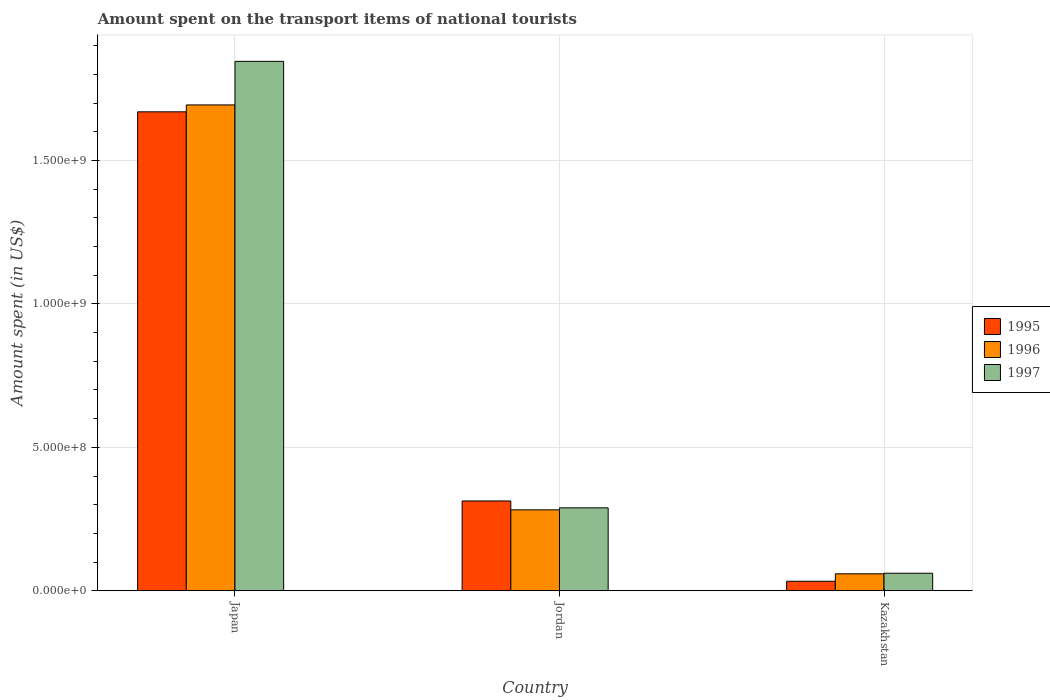How many different coloured bars are there?
Keep it short and to the point. 3. Are the number of bars per tick equal to the number of legend labels?
Provide a short and direct response. Yes. How many bars are there on the 2nd tick from the left?
Provide a succinct answer. 3. What is the label of the 1st group of bars from the left?
Your response must be concise. Japan. In how many cases, is the number of bars for a given country not equal to the number of legend labels?
Ensure brevity in your answer.  0. What is the amount spent on the transport items of national tourists in 1996 in Kazakhstan?
Ensure brevity in your answer.  5.90e+07. Across all countries, what is the maximum amount spent on the transport items of national tourists in 1995?
Ensure brevity in your answer.  1.67e+09. Across all countries, what is the minimum amount spent on the transport items of national tourists in 1995?
Keep it short and to the point. 3.30e+07. In which country was the amount spent on the transport items of national tourists in 1995 maximum?
Make the answer very short. Japan. In which country was the amount spent on the transport items of national tourists in 1997 minimum?
Give a very brief answer. Kazakhstan. What is the total amount spent on the transport items of national tourists in 1995 in the graph?
Your answer should be very brief. 2.02e+09. What is the difference between the amount spent on the transport items of national tourists in 1996 in Japan and that in Jordan?
Keep it short and to the point. 1.41e+09. What is the difference between the amount spent on the transport items of national tourists in 1997 in Jordan and the amount spent on the transport items of national tourists in 1995 in Japan?
Give a very brief answer. -1.38e+09. What is the average amount spent on the transport items of national tourists in 1997 per country?
Make the answer very short. 7.32e+08. What is the difference between the amount spent on the transport items of national tourists of/in 1997 and amount spent on the transport items of national tourists of/in 1995 in Jordan?
Provide a short and direct response. -2.40e+07. What is the ratio of the amount spent on the transport items of national tourists in 1995 in Japan to that in Jordan?
Your response must be concise. 5.34. Is the amount spent on the transport items of national tourists in 1997 in Jordan less than that in Kazakhstan?
Provide a succinct answer. No. Is the difference between the amount spent on the transport items of national tourists in 1997 in Japan and Kazakhstan greater than the difference between the amount spent on the transport items of national tourists in 1995 in Japan and Kazakhstan?
Your response must be concise. Yes. What is the difference between the highest and the second highest amount spent on the transport items of national tourists in 1996?
Offer a very short reply. 1.41e+09. What is the difference between the highest and the lowest amount spent on the transport items of national tourists in 1997?
Keep it short and to the point. 1.78e+09. Is the sum of the amount spent on the transport items of national tourists in 1995 in Japan and Kazakhstan greater than the maximum amount spent on the transport items of national tourists in 1996 across all countries?
Your response must be concise. Yes. What does the 2nd bar from the right in Kazakhstan represents?
Give a very brief answer. 1996. Is it the case that in every country, the sum of the amount spent on the transport items of national tourists in 1997 and amount spent on the transport items of national tourists in 1996 is greater than the amount spent on the transport items of national tourists in 1995?
Provide a succinct answer. Yes. How many bars are there?
Give a very brief answer. 9. Are all the bars in the graph horizontal?
Offer a very short reply. No. How many countries are there in the graph?
Make the answer very short. 3. Are the values on the major ticks of Y-axis written in scientific E-notation?
Ensure brevity in your answer.  Yes. Does the graph contain any zero values?
Offer a terse response. No. Does the graph contain grids?
Provide a short and direct response. Yes. How many legend labels are there?
Provide a short and direct response. 3. What is the title of the graph?
Provide a succinct answer. Amount spent on the transport items of national tourists. What is the label or title of the Y-axis?
Provide a succinct answer. Amount spent (in US$). What is the Amount spent (in US$) in 1995 in Japan?
Make the answer very short. 1.67e+09. What is the Amount spent (in US$) of 1996 in Japan?
Your answer should be very brief. 1.69e+09. What is the Amount spent (in US$) in 1997 in Japan?
Your answer should be very brief. 1.85e+09. What is the Amount spent (in US$) in 1995 in Jordan?
Your answer should be compact. 3.13e+08. What is the Amount spent (in US$) of 1996 in Jordan?
Provide a succinct answer. 2.82e+08. What is the Amount spent (in US$) in 1997 in Jordan?
Provide a succinct answer. 2.89e+08. What is the Amount spent (in US$) of 1995 in Kazakhstan?
Give a very brief answer. 3.30e+07. What is the Amount spent (in US$) of 1996 in Kazakhstan?
Your answer should be very brief. 5.90e+07. What is the Amount spent (in US$) of 1997 in Kazakhstan?
Keep it short and to the point. 6.10e+07. Across all countries, what is the maximum Amount spent (in US$) of 1995?
Your answer should be compact. 1.67e+09. Across all countries, what is the maximum Amount spent (in US$) in 1996?
Make the answer very short. 1.69e+09. Across all countries, what is the maximum Amount spent (in US$) in 1997?
Make the answer very short. 1.85e+09. Across all countries, what is the minimum Amount spent (in US$) in 1995?
Give a very brief answer. 3.30e+07. Across all countries, what is the minimum Amount spent (in US$) of 1996?
Offer a terse response. 5.90e+07. Across all countries, what is the minimum Amount spent (in US$) of 1997?
Your answer should be compact. 6.10e+07. What is the total Amount spent (in US$) in 1995 in the graph?
Your answer should be very brief. 2.02e+09. What is the total Amount spent (in US$) of 1996 in the graph?
Ensure brevity in your answer.  2.04e+09. What is the total Amount spent (in US$) in 1997 in the graph?
Offer a terse response. 2.20e+09. What is the difference between the Amount spent (in US$) of 1995 in Japan and that in Jordan?
Make the answer very short. 1.36e+09. What is the difference between the Amount spent (in US$) in 1996 in Japan and that in Jordan?
Provide a short and direct response. 1.41e+09. What is the difference between the Amount spent (in US$) in 1997 in Japan and that in Jordan?
Provide a short and direct response. 1.56e+09. What is the difference between the Amount spent (in US$) of 1995 in Japan and that in Kazakhstan?
Keep it short and to the point. 1.64e+09. What is the difference between the Amount spent (in US$) in 1996 in Japan and that in Kazakhstan?
Offer a terse response. 1.64e+09. What is the difference between the Amount spent (in US$) of 1997 in Japan and that in Kazakhstan?
Keep it short and to the point. 1.78e+09. What is the difference between the Amount spent (in US$) of 1995 in Jordan and that in Kazakhstan?
Make the answer very short. 2.80e+08. What is the difference between the Amount spent (in US$) of 1996 in Jordan and that in Kazakhstan?
Offer a terse response. 2.23e+08. What is the difference between the Amount spent (in US$) in 1997 in Jordan and that in Kazakhstan?
Keep it short and to the point. 2.28e+08. What is the difference between the Amount spent (in US$) in 1995 in Japan and the Amount spent (in US$) in 1996 in Jordan?
Provide a succinct answer. 1.39e+09. What is the difference between the Amount spent (in US$) of 1995 in Japan and the Amount spent (in US$) of 1997 in Jordan?
Keep it short and to the point. 1.38e+09. What is the difference between the Amount spent (in US$) in 1996 in Japan and the Amount spent (in US$) in 1997 in Jordan?
Make the answer very short. 1.40e+09. What is the difference between the Amount spent (in US$) of 1995 in Japan and the Amount spent (in US$) of 1996 in Kazakhstan?
Keep it short and to the point. 1.61e+09. What is the difference between the Amount spent (in US$) of 1995 in Japan and the Amount spent (in US$) of 1997 in Kazakhstan?
Provide a short and direct response. 1.61e+09. What is the difference between the Amount spent (in US$) in 1996 in Japan and the Amount spent (in US$) in 1997 in Kazakhstan?
Make the answer very short. 1.63e+09. What is the difference between the Amount spent (in US$) of 1995 in Jordan and the Amount spent (in US$) of 1996 in Kazakhstan?
Provide a short and direct response. 2.54e+08. What is the difference between the Amount spent (in US$) of 1995 in Jordan and the Amount spent (in US$) of 1997 in Kazakhstan?
Offer a very short reply. 2.52e+08. What is the difference between the Amount spent (in US$) of 1996 in Jordan and the Amount spent (in US$) of 1997 in Kazakhstan?
Provide a short and direct response. 2.21e+08. What is the average Amount spent (in US$) of 1995 per country?
Give a very brief answer. 6.72e+08. What is the average Amount spent (in US$) in 1996 per country?
Give a very brief answer. 6.78e+08. What is the average Amount spent (in US$) of 1997 per country?
Your answer should be compact. 7.32e+08. What is the difference between the Amount spent (in US$) of 1995 and Amount spent (in US$) of 1996 in Japan?
Make the answer very short. -2.40e+07. What is the difference between the Amount spent (in US$) of 1995 and Amount spent (in US$) of 1997 in Japan?
Your response must be concise. -1.76e+08. What is the difference between the Amount spent (in US$) of 1996 and Amount spent (in US$) of 1997 in Japan?
Offer a terse response. -1.52e+08. What is the difference between the Amount spent (in US$) in 1995 and Amount spent (in US$) in 1996 in Jordan?
Your answer should be very brief. 3.10e+07. What is the difference between the Amount spent (in US$) of 1995 and Amount spent (in US$) of 1997 in Jordan?
Your answer should be very brief. 2.40e+07. What is the difference between the Amount spent (in US$) in 1996 and Amount spent (in US$) in 1997 in Jordan?
Give a very brief answer. -7.00e+06. What is the difference between the Amount spent (in US$) of 1995 and Amount spent (in US$) of 1996 in Kazakhstan?
Provide a short and direct response. -2.60e+07. What is the difference between the Amount spent (in US$) of 1995 and Amount spent (in US$) of 1997 in Kazakhstan?
Your answer should be compact. -2.80e+07. What is the difference between the Amount spent (in US$) of 1996 and Amount spent (in US$) of 1997 in Kazakhstan?
Keep it short and to the point. -2.00e+06. What is the ratio of the Amount spent (in US$) of 1995 in Japan to that in Jordan?
Make the answer very short. 5.34. What is the ratio of the Amount spent (in US$) of 1996 in Japan to that in Jordan?
Your answer should be compact. 6.01. What is the ratio of the Amount spent (in US$) of 1997 in Japan to that in Jordan?
Your response must be concise. 6.39. What is the ratio of the Amount spent (in US$) of 1995 in Japan to that in Kazakhstan?
Offer a very short reply. 50.61. What is the ratio of the Amount spent (in US$) of 1996 in Japan to that in Kazakhstan?
Offer a terse response. 28.71. What is the ratio of the Amount spent (in US$) of 1997 in Japan to that in Kazakhstan?
Keep it short and to the point. 30.26. What is the ratio of the Amount spent (in US$) of 1995 in Jordan to that in Kazakhstan?
Keep it short and to the point. 9.48. What is the ratio of the Amount spent (in US$) of 1996 in Jordan to that in Kazakhstan?
Keep it short and to the point. 4.78. What is the ratio of the Amount spent (in US$) in 1997 in Jordan to that in Kazakhstan?
Your response must be concise. 4.74. What is the difference between the highest and the second highest Amount spent (in US$) in 1995?
Provide a succinct answer. 1.36e+09. What is the difference between the highest and the second highest Amount spent (in US$) of 1996?
Ensure brevity in your answer.  1.41e+09. What is the difference between the highest and the second highest Amount spent (in US$) of 1997?
Give a very brief answer. 1.56e+09. What is the difference between the highest and the lowest Amount spent (in US$) of 1995?
Your answer should be compact. 1.64e+09. What is the difference between the highest and the lowest Amount spent (in US$) of 1996?
Provide a short and direct response. 1.64e+09. What is the difference between the highest and the lowest Amount spent (in US$) in 1997?
Your response must be concise. 1.78e+09. 